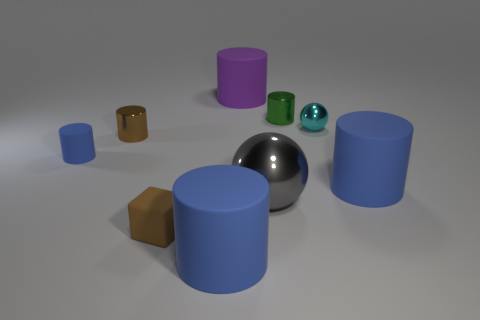Subtract all yellow balls. How many blue cylinders are left? 3 Subtract all green metal cylinders. How many cylinders are left? 5 Subtract all purple cylinders. How many cylinders are left? 5 Subtract all gray cylinders. Subtract all cyan blocks. How many cylinders are left? 6 Add 1 tiny yellow metal cylinders. How many objects exist? 10 Subtract all spheres. How many objects are left? 7 Add 7 big gray shiny spheres. How many big gray shiny spheres are left? 8 Add 7 blue things. How many blue things exist? 10 Subtract 1 brown cubes. How many objects are left? 8 Subtract all matte cubes. Subtract all big purple things. How many objects are left? 7 